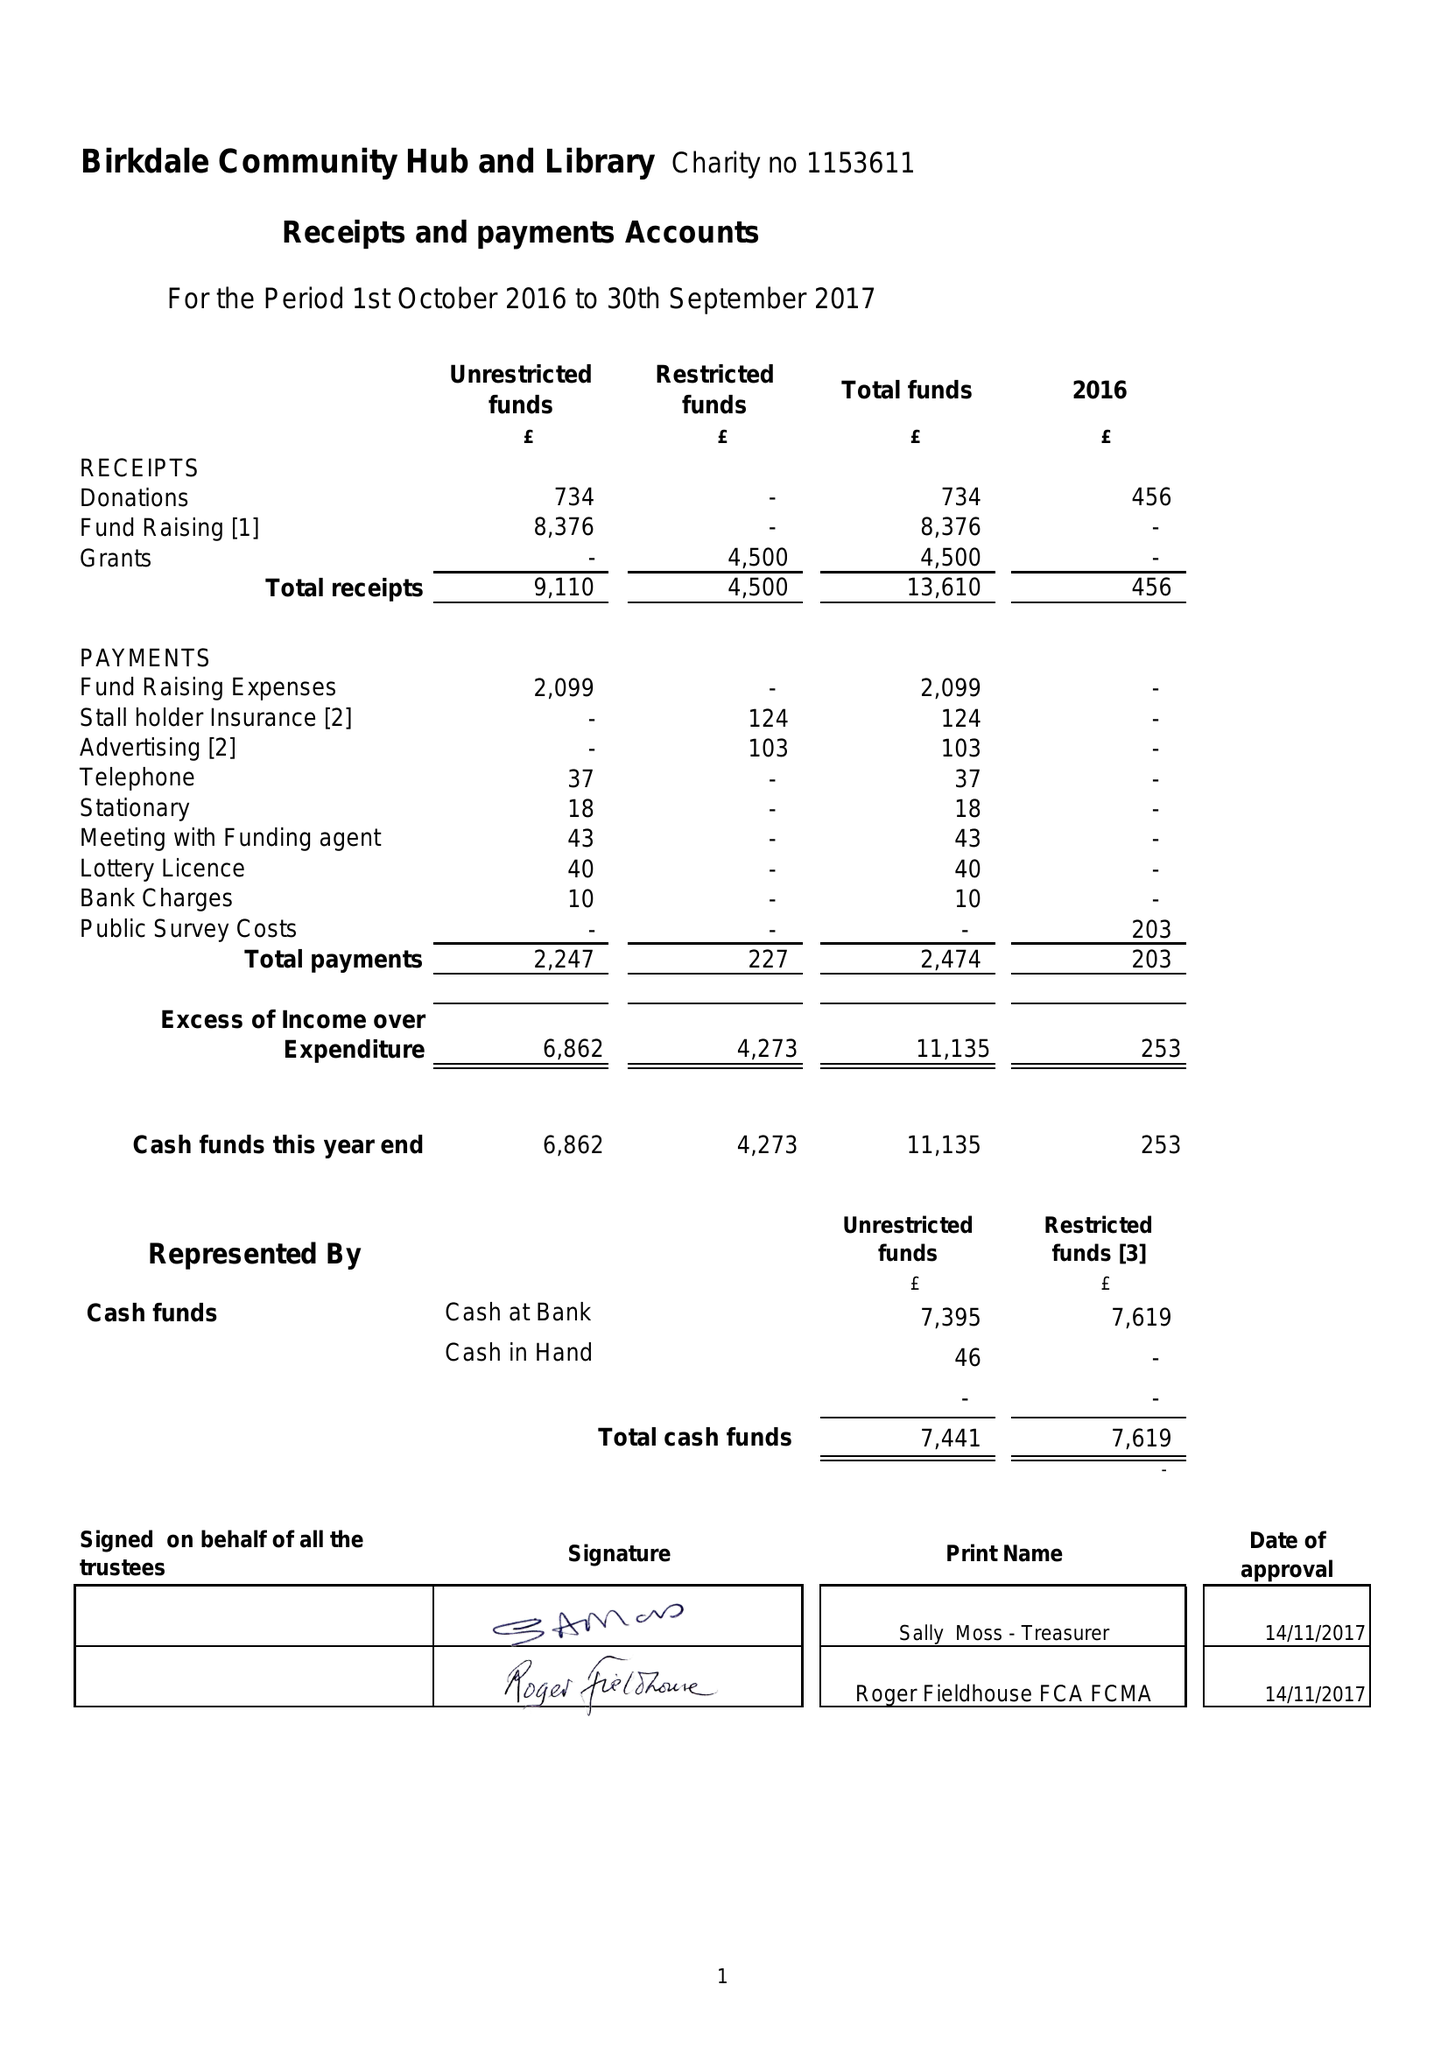What is the value for the address__postcode?
Answer the question using a single word or phrase. PR8 3QS 